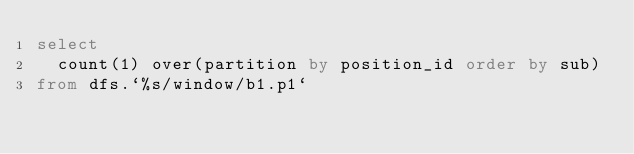<code> <loc_0><loc_0><loc_500><loc_500><_SQL_>select
  count(1) over(partition by position_id order by sub)
from dfs.`%s/window/b1.p1`
</code> 